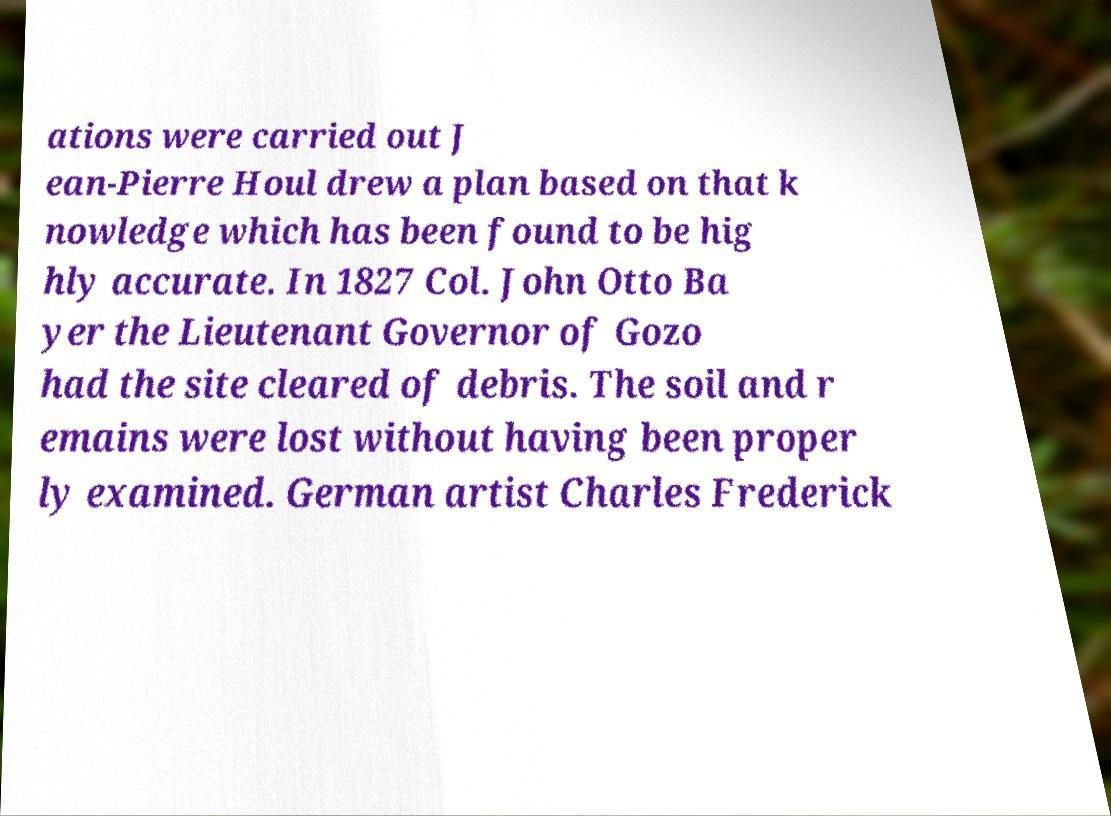There's text embedded in this image that I need extracted. Can you transcribe it verbatim? ations were carried out J ean-Pierre Houl drew a plan based on that k nowledge which has been found to be hig hly accurate. In 1827 Col. John Otto Ba yer the Lieutenant Governor of Gozo had the site cleared of debris. The soil and r emains were lost without having been proper ly examined. German artist Charles Frederick 